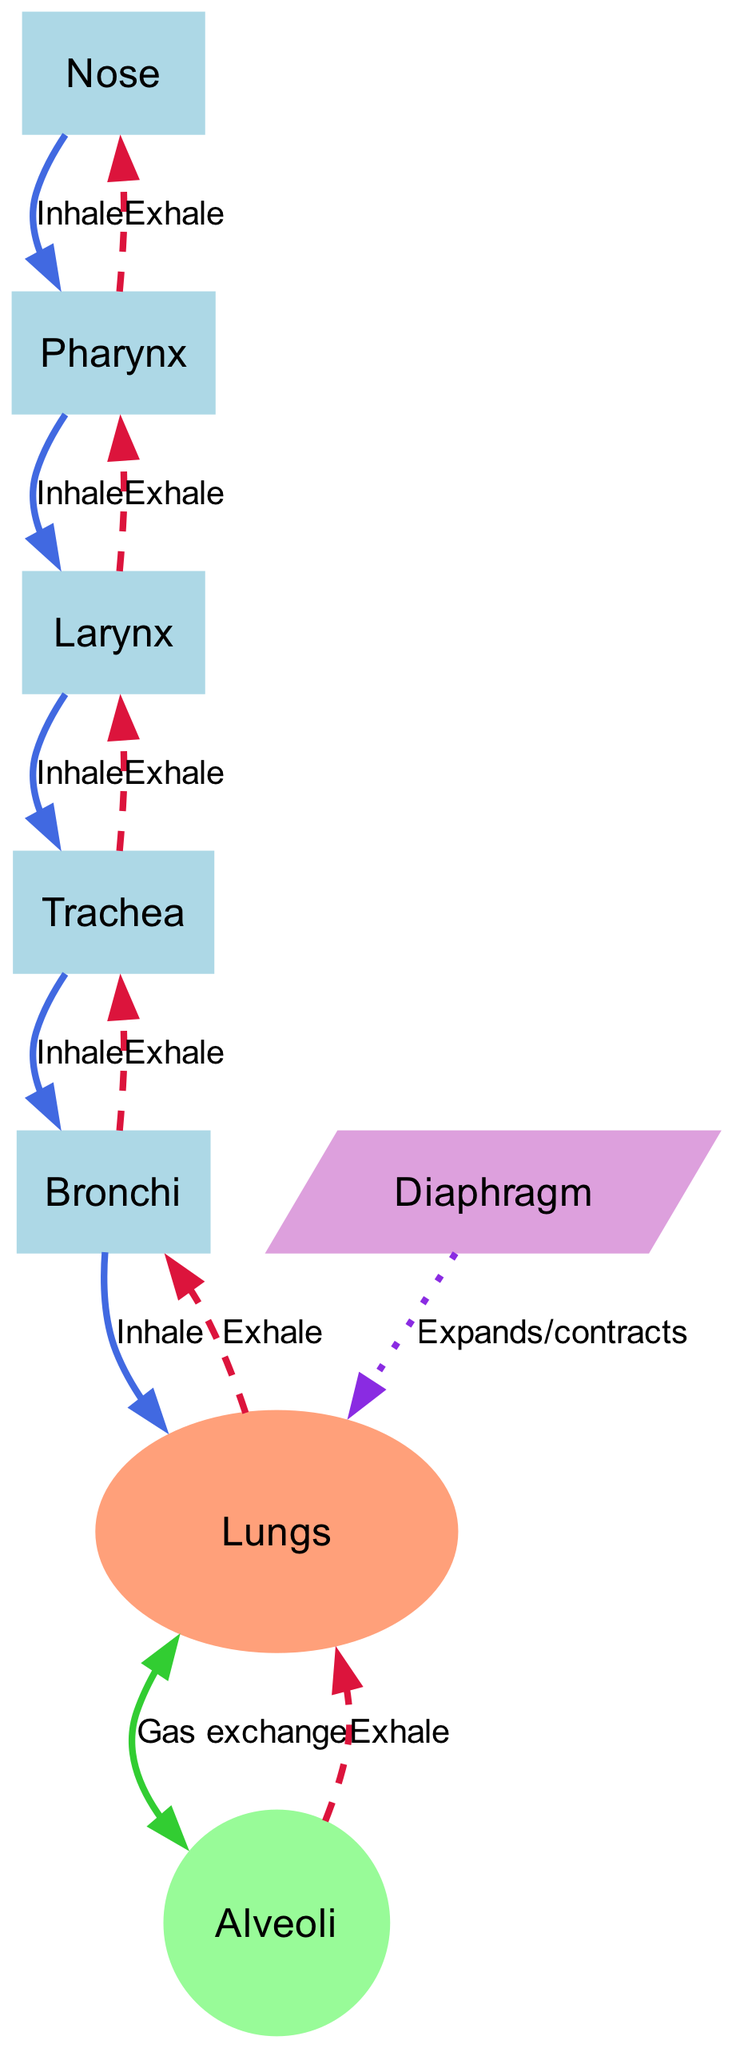What is the first part of the respiratory system where air enters? The diagram indicates that air enters through the Nose. Since it is the first labeled node in the airflow direction, we identify it as the entry point of the respiratory system.
Answer: Nose How many nodes are present in the diagram? The diagram includes a total of 8 nodes, which are the labeled parts of the respiratory system: Nose, Pharynx, Larynx, Trachea, Bronchi, Lungs, Alveoli, and Diaphragm. Counting these gives us the total.
Answer: 8 What is the last part air reaches during inhalation? The last part of the respiratory system that air reaches during inhalation is the Alveoli. Following the labeled edges, inhalation flows through from the Nose to the Pharynx, Larynx, Trachea, Bronchi, and finally to the Lungs, before reaching the Alveoli.
Answer: Alveoli Which structure is involved in gas exchange? The diagram specifies that the Alveoli are the structures involved in gas exchange, as indicated by the edge labeled "Gas exchange" connecting Lungs to Alveoli.
Answer: Alveoli What direction of airflow is indicated between the Alveoli and the Lungs during exhalation? The diagram shows that the airflow is from Alveoli to Lungs during exhalation, as indicated by the labeled edge in the reverse direction with "Exhale." This marks the flow of air out from the gas exchange site back into the Lungs.
Answer: Exhale How does air pass from the Diaphragm to the Lungs? The diagram illustrates that the Diaphragm expands/contracts to facilitate airflow into the Lungs. The edge labeled "Expands/contracts" indicates this action, enabling movement of air through the respiratory system.
Answer: Expands/contracts What color is used for the edge that indicates exhalation? The edges that indicate exhalation are shown in a dashed red color, represented as "#DC143C" in the diagram, which helps differentiate them from inhalation edges.
Answer: Dashed red Which part of the respiratory system is oval-shaped? The Lungs are depicted as an oval shape in the diagram, highlighted to distinguish them from other nodes based on their graphical representation. This is specifically mentioned in the node attributes.
Answer: Lungs 